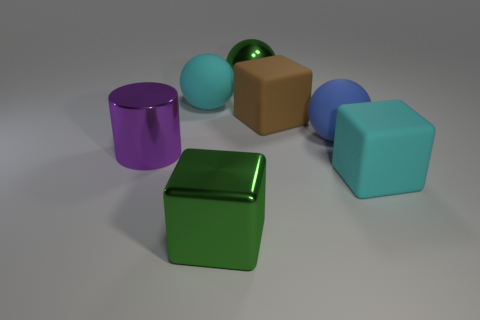Add 2 tiny brown cubes. How many objects exist? 9 Subtract all balls. How many objects are left? 4 Subtract all blue matte spheres. Subtract all cyan matte spheres. How many objects are left? 5 Add 7 large cyan spheres. How many large cyan spheres are left? 8 Add 6 tiny cyan cylinders. How many tiny cyan cylinders exist? 6 Subtract 0 green cylinders. How many objects are left? 7 